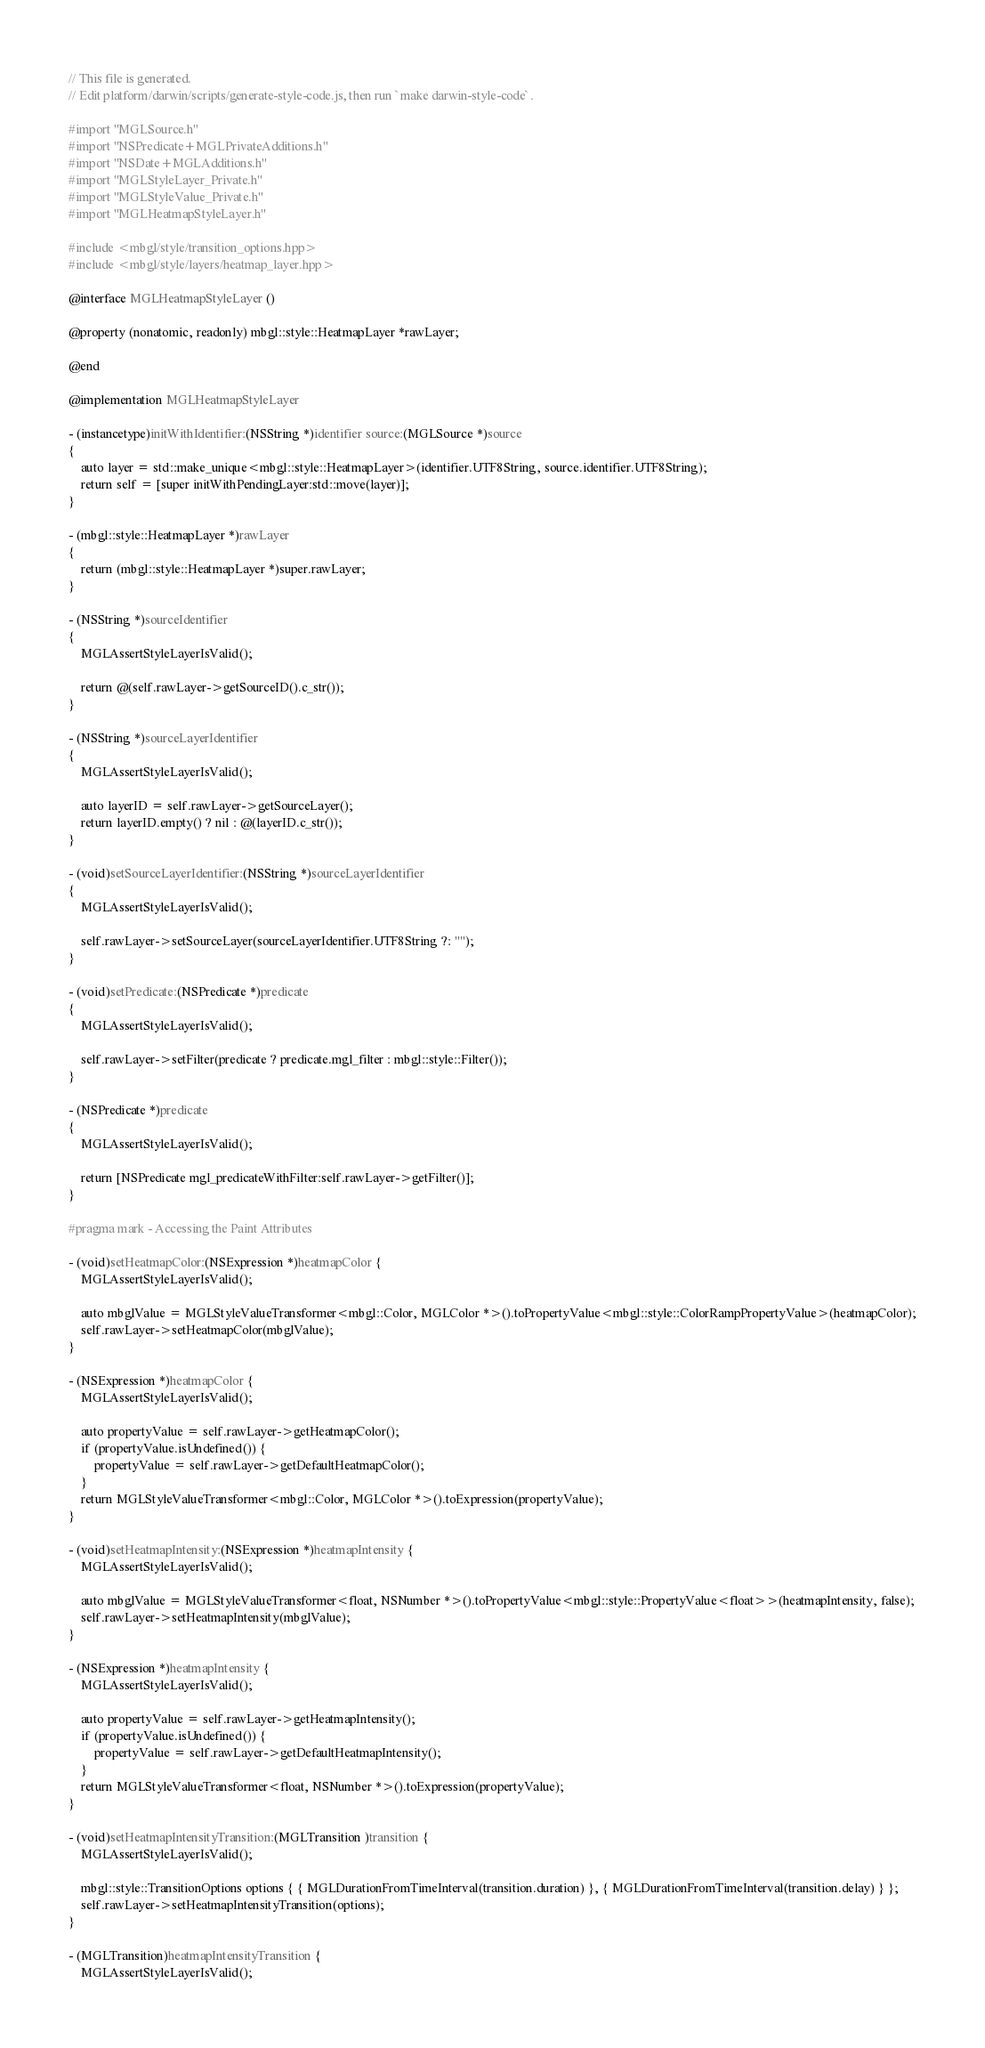Convert code to text. <code><loc_0><loc_0><loc_500><loc_500><_ObjectiveC_>// This file is generated.
// Edit platform/darwin/scripts/generate-style-code.js, then run `make darwin-style-code`.

#import "MGLSource.h"
#import "NSPredicate+MGLPrivateAdditions.h"
#import "NSDate+MGLAdditions.h"
#import "MGLStyleLayer_Private.h"
#import "MGLStyleValue_Private.h"
#import "MGLHeatmapStyleLayer.h"

#include <mbgl/style/transition_options.hpp>
#include <mbgl/style/layers/heatmap_layer.hpp>

@interface MGLHeatmapStyleLayer ()

@property (nonatomic, readonly) mbgl::style::HeatmapLayer *rawLayer;

@end

@implementation MGLHeatmapStyleLayer

- (instancetype)initWithIdentifier:(NSString *)identifier source:(MGLSource *)source
{
    auto layer = std::make_unique<mbgl::style::HeatmapLayer>(identifier.UTF8String, source.identifier.UTF8String);
    return self = [super initWithPendingLayer:std::move(layer)];
}

- (mbgl::style::HeatmapLayer *)rawLayer
{
    return (mbgl::style::HeatmapLayer *)super.rawLayer;
}

- (NSString *)sourceIdentifier
{
    MGLAssertStyleLayerIsValid();

    return @(self.rawLayer->getSourceID().c_str());
}

- (NSString *)sourceLayerIdentifier
{
    MGLAssertStyleLayerIsValid();

    auto layerID = self.rawLayer->getSourceLayer();
    return layerID.empty() ? nil : @(layerID.c_str());
}

- (void)setSourceLayerIdentifier:(NSString *)sourceLayerIdentifier
{
    MGLAssertStyleLayerIsValid();

    self.rawLayer->setSourceLayer(sourceLayerIdentifier.UTF8String ?: "");
}

- (void)setPredicate:(NSPredicate *)predicate
{
    MGLAssertStyleLayerIsValid();

    self.rawLayer->setFilter(predicate ? predicate.mgl_filter : mbgl::style::Filter());
}

- (NSPredicate *)predicate
{
    MGLAssertStyleLayerIsValid();

    return [NSPredicate mgl_predicateWithFilter:self.rawLayer->getFilter()];
}

#pragma mark - Accessing the Paint Attributes

- (void)setHeatmapColor:(NSExpression *)heatmapColor {
    MGLAssertStyleLayerIsValid();

    auto mbglValue = MGLStyleValueTransformer<mbgl::Color, MGLColor *>().toPropertyValue<mbgl::style::ColorRampPropertyValue>(heatmapColor);
    self.rawLayer->setHeatmapColor(mbglValue);
}

- (NSExpression *)heatmapColor {
    MGLAssertStyleLayerIsValid();

    auto propertyValue = self.rawLayer->getHeatmapColor();
    if (propertyValue.isUndefined()) {
        propertyValue = self.rawLayer->getDefaultHeatmapColor();
    }
    return MGLStyleValueTransformer<mbgl::Color, MGLColor *>().toExpression(propertyValue);
}

- (void)setHeatmapIntensity:(NSExpression *)heatmapIntensity {
    MGLAssertStyleLayerIsValid();

    auto mbglValue = MGLStyleValueTransformer<float, NSNumber *>().toPropertyValue<mbgl::style::PropertyValue<float>>(heatmapIntensity, false);
    self.rawLayer->setHeatmapIntensity(mbglValue);
}

- (NSExpression *)heatmapIntensity {
    MGLAssertStyleLayerIsValid();

    auto propertyValue = self.rawLayer->getHeatmapIntensity();
    if (propertyValue.isUndefined()) {
        propertyValue = self.rawLayer->getDefaultHeatmapIntensity();
    }
    return MGLStyleValueTransformer<float, NSNumber *>().toExpression(propertyValue);
}

- (void)setHeatmapIntensityTransition:(MGLTransition )transition {
    MGLAssertStyleLayerIsValid();

    mbgl::style::TransitionOptions options { { MGLDurationFromTimeInterval(transition.duration) }, { MGLDurationFromTimeInterval(transition.delay) } };
    self.rawLayer->setHeatmapIntensityTransition(options);
}

- (MGLTransition)heatmapIntensityTransition {
    MGLAssertStyleLayerIsValid();
</code> 